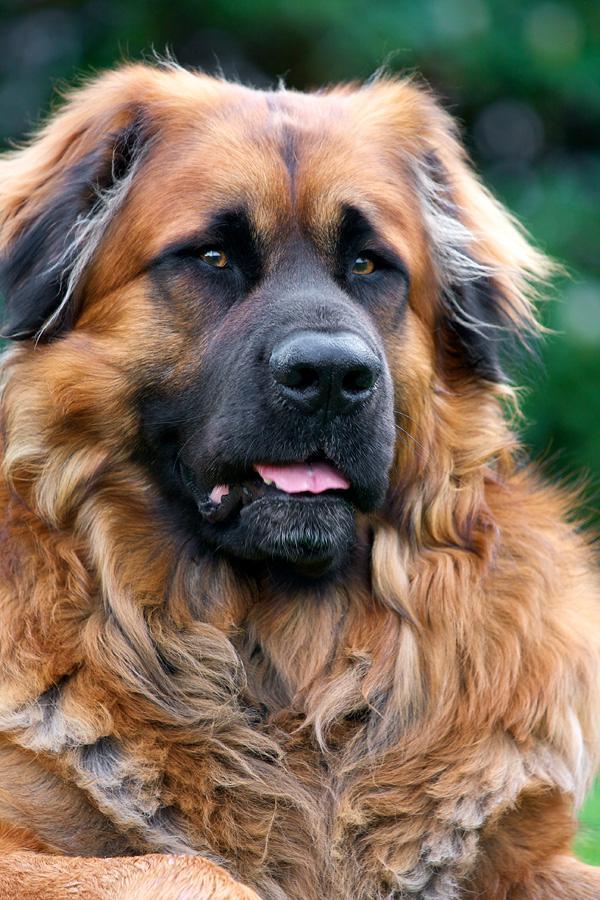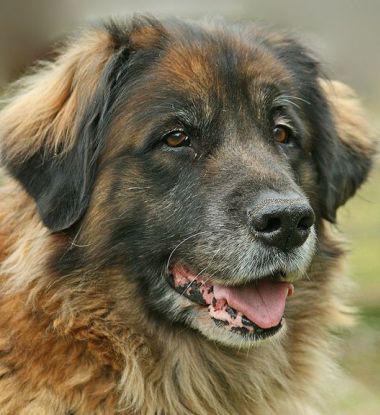The first image is the image on the left, the second image is the image on the right. For the images displayed, is the sentence "One image is shot indoors with furniture and one image is outdoors with grass." factually correct? Answer yes or no. No. The first image is the image on the left, the second image is the image on the right. Analyze the images presented: Is the assertion "There are two dogs total." valid? Answer yes or no. Yes. 